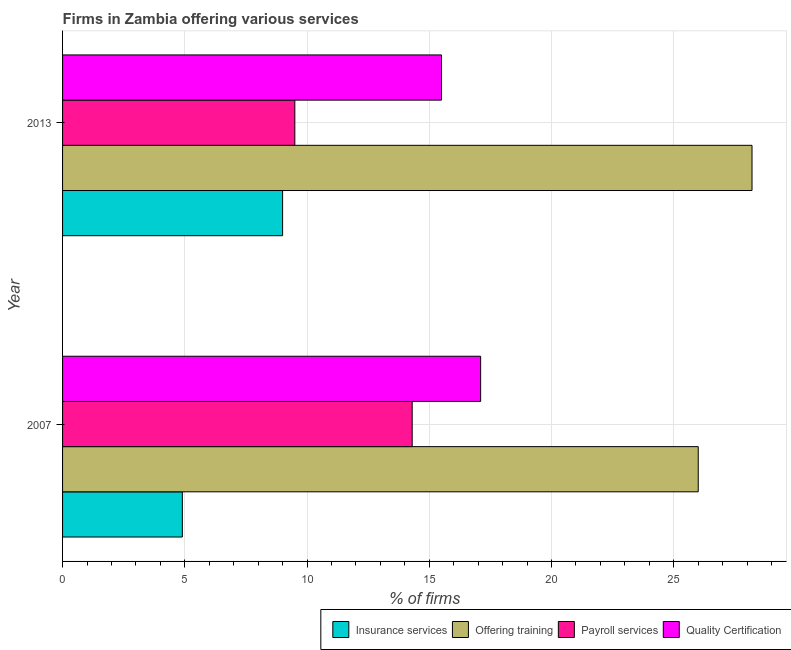How many different coloured bars are there?
Give a very brief answer. 4. How many groups of bars are there?
Provide a succinct answer. 2. Are the number of bars on each tick of the Y-axis equal?
Offer a terse response. Yes. How many bars are there on the 1st tick from the bottom?
Keep it short and to the point. 4. What is the label of the 1st group of bars from the top?
Provide a succinct answer. 2013. In how many cases, is the number of bars for a given year not equal to the number of legend labels?
Ensure brevity in your answer.  0. What is the percentage of firms offering quality certification in 2007?
Your response must be concise. 17.1. Across all years, what is the maximum percentage of firms offering insurance services?
Keep it short and to the point. 9. Across all years, what is the minimum percentage of firms offering quality certification?
Keep it short and to the point. 15.5. In which year was the percentage of firms offering quality certification maximum?
Your answer should be very brief. 2007. In which year was the percentage of firms offering training minimum?
Ensure brevity in your answer.  2007. What is the total percentage of firms offering quality certification in the graph?
Provide a succinct answer. 32.6. What is the difference between the percentage of firms offering quality certification in 2013 and the percentage of firms offering training in 2007?
Your answer should be compact. -10.5. What is the average percentage of firms offering insurance services per year?
Ensure brevity in your answer.  6.95. In the year 2013, what is the difference between the percentage of firms offering insurance services and percentage of firms offering training?
Provide a succinct answer. -19.2. In how many years, is the percentage of firms offering payroll services greater than 2 %?
Ensure brevity in your answer.  2. What is the ratio of the percentage of firms offering quality certification in 2007 to that in 2013?
Ensure brevity in your answer.  1.1. What does the 4th bar from the top in 2007 represents?
Your answer should be very brief. Insurance services. What does the 4th bar from the bottom in 2013 represents?
Provide a succinct answer. Quality Certification. Is it the case that in every year, the sum of the percentage of firms offering insurance services and percentage of firms offering training is greater than the percentage of firms offering payroll services?
Give a very brief answer. Yes. Are all the bars in the graph horizontal?
Offer a very short reply. Yes. How many legend labels are there?
Your answer should be very brief. 4. How are the legend labels stacked?
Provide a short and direct response. Horizontal. What is the title of the graph?
Offer a terse response. Firms in Zambia offering various services . Does "Building human resources" appear as one of the legend labels in the graph?
Provide a succinct answer. No. What is the label or title of the X-axis?
Keep it short and to the point. % of firms. What is the % of firms of Offering training in 2007?
Offer a very short reply. 26. What is the % of firms in Quality Certification in 2007?
Offer a very short reply. 17.1. What is the % of firms in Insurance services in 2013?
Give a very brief answer. 9. What is the % of firms in Offering training in 2013?
Ensure brevity in your answer.  28.2. Across all years, what is the maximum % of firms of Insurance services?
Offer a terse response. 9. Across all years, what is the maximum % of firms of Offering training?
Ensure brevity in your answer.  28.2. Across all years, what is the minimum % of firms in Payroll services?
Give a very brief answer. 9.5. What is the total % of firms in Insurance services in the graph?
Provide a short and direct response. 13.9. What is the total % of firms of Offering training in the graph?
Provide a short and direct response. 54.2. What is the total % of firms of Payroll services in the graph?
Offer a terse response. 23.8. What is the total % of firms of Quality Certification in the graph?
Provide a succinct answer. 32.6. What is the difference between the % of firms in Insurance services in 2007 and that in 2013?
Provide a short and direct response. -4.1. What is the difference between the % of firms of Offering training in 2007 and that in 2013?
Offer a terse response. -2.2. What is the difference between the % of firms of Insurance services in 2007 and the % of firms of Offering training in 2013?
Offer a very short reply. -23.3. What is the difference between the % of firms in Offering training in 2007 and the % of firms in Payroll services in 2013?
Ensure brevity in your answer.  16.5. What is the difference between the % of firms of Offering training in 2007 and the % of firms of Quality Certification in 2013?
Provide a succinct answer. 10.5. What is the difference between the % of firms of Payroll services in 2007 and the % of firms of Quality Certification in 2013?
Your answer should be very brief. -1.2. What is the average % of firms in Insurance services per year?
Provide a short and direct response. 6.95. What is the average % of firms of Offering training per year?
Provide a succinct answer. 27.1. What is the average % of firms in Payroll services per year?
Your answer should be very brief. 11.9. What is the average % of firms in Quality Certification per year?
Make the answer very short. 16.3. In the year 2007, what is the difference between the % of firms in Insurance services and % of firms in Offering training?
Provide a succinct answer. -21.1. In the year 2007, what is the difference between the % of firms of Payroll services and % of firms of Quality Certification?
Provide a succinct answer. -2.8. In the year 2013, what is the difference between the % of firms in Insurance services and % of firms in Offering training?
Your response must be concise. -19.2. In the year 2013, what is the difference between the % of firms in Insurance services and % of firms in Quality Certification?
Give a very brief answer. -6.5. In the year 2013, what is the difference between the % of firms of Offering training and % of firms of Payroll services?
Provide a short and direct response. 18.7. In the year 2013, what is the difference between the % of firms of Offering training and % of firms of Quality Certification?
Give a very brief answer. 12.7. What is the ratio of the % of firms of Insurance services in 2007 to that in 2013?
Keep it short and to the point. 0.54. What is the ratio of the % of firms in Offering training in 2007 to that in 2013?
Provide a succinct answer. 0.92. What is the ratio of the % of firms of Payroll services in 2007 to that in 2013?
Keep it short and to the point. 1.51. What is the ratio of the % of firms of Quality Certification in 2007 to that in 2013?
Offer a very short reply. 1.1. What is the difference between the highest and the second highest % of firms of Insurance services?
Make the answer very short. 4.1. What is the difference between the highest and the second highest % of firms of Offering training?
Give a very brief answer. 2.2. What is the difference between the highest and the second highest % of firms of Payroll services?
Offer a very short reply. 4.8. What is the difference between the highest and the second highest % of firms of Quality Certification?
Your answer should be compact. 1.6. What is the difference between the highest and the lowest % of firms in Insurance services?
Keep it short and to the point. 4.1. What is the difference between the highest and the lowest % of firms in Offering training?
Offer a terse response. 2.2. What is the difference between the highest and the lowest % of firms in Payroll services?
Your answer should be very brief. 4.8. What is the difference between the highest and the lowest % of firms in Quality Certification?
Ensure brevity in your answer.  1.6. 